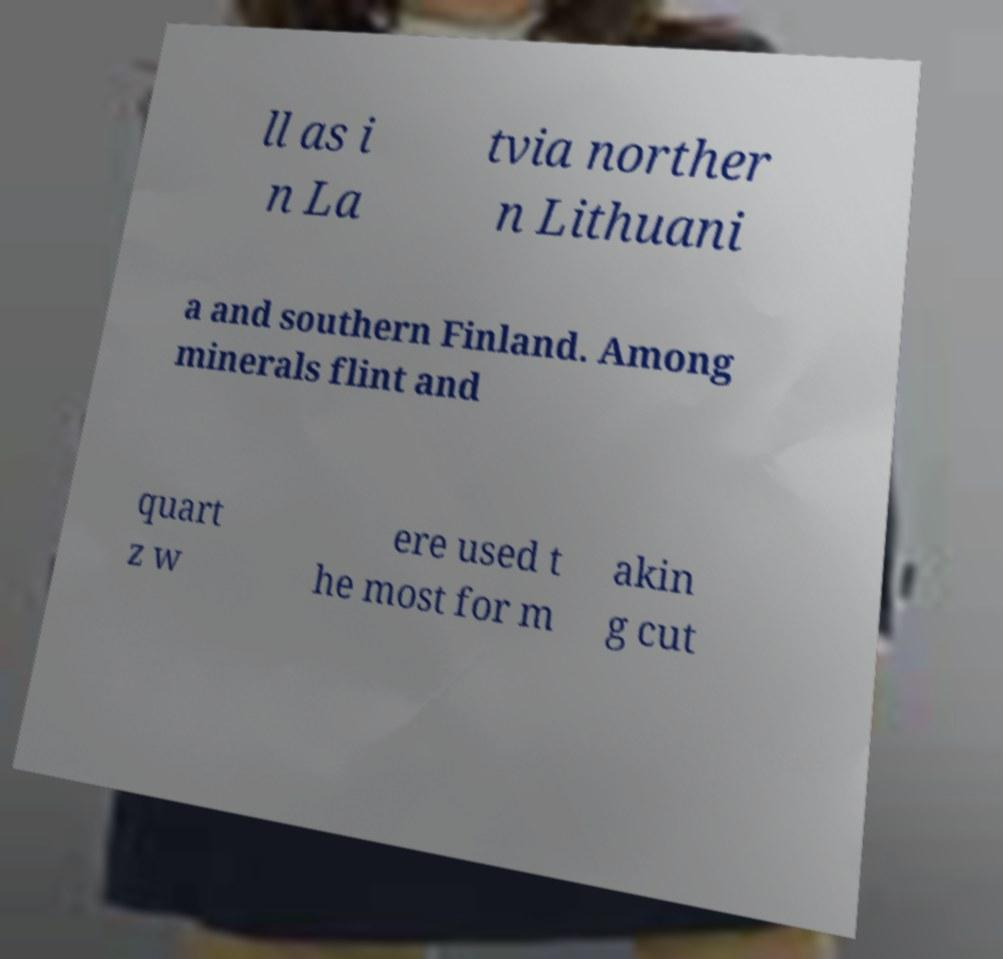Can you accurately transcribe the text from the provided image for me? ll as i n La tvia norther n Lithuani a and southern Finland. Among minerals flint and quart z w ere used t he most for m akin g cut 